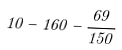<formula> <loc_0><loc_0><loc_500><loc_500>1 0 - 1 6 0 - \frac { 6 9 } { 1 5 0 }</formula> 